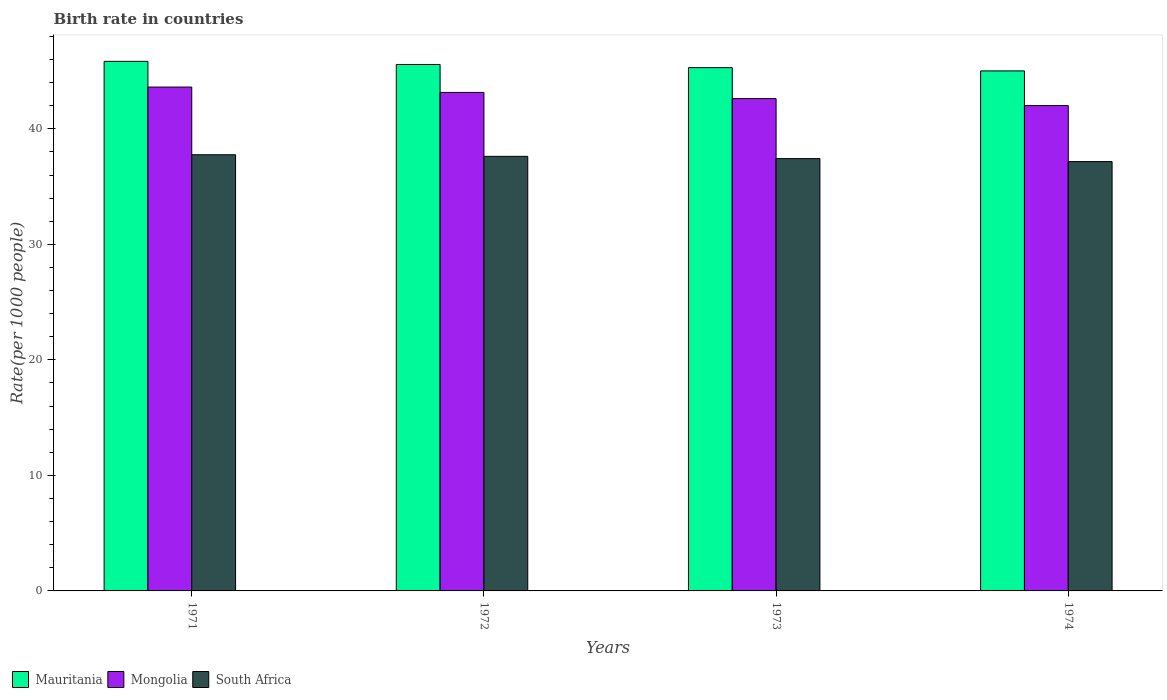How many different coloured bars are there?
Give a very brief answer. 3. Are the number of bars on each tick of the X-axis equal?
Provide a succinct answer. Yes. How many bars are there on the 4th tick from the left?
Your answer should be very brief. 3. What is the birth rate in Mongolia in 1973?
Provide a short and direct response. 42.61. Across all years, what is the maximum birth rate in Mongolia?
Offer a very short reply. 43.61. Across all years, what is the minimum birth rate in South Africa?
Offer a terse response. 37.16. In which year was the birth rate in Mongolia minimum?
Your answer should be very brief. 1974. What is the total birth rate in Mauritania in the graph?
Your response must be concise. 181.71. What is the difference between the birth rate in South Africa in 1972 and that in 1974?
Offer a terse response. 0.45. What is the difference between the birth rate in South Africa in 1972 and the birth rate in Mauritania in 1971?
Keep it short and to the point. -8.22. What is the average birth rate in South Africa per year?
Make the answer very short. 37.49. In the year 1972, what is the difference between the birth rate in Mongolia and birth rate in Mauritania?
Provide a short and direct response. -2.42. What is the ratio of the birth rate in South Africa in 1972 to that in 1973?
Provide a short and direct response. 1.01. Is the birth rate in South Africa in 1973 less than that in 1974?
Keep it short and to the point. No. Is the difference between the birth rate in Mongolia in 1971 and 1973 greater than the difference between the birth rate in Mauritania in 1971 and 1973?
Provide a succinct answer. Yes. What is the difference between the highest and the second highest birth rate in Mauritania?
Your answer should be very brief. 0.27. What is the difference between the highest and the lowest birth rate in Mongolia?
Your answer should be compact. 1.6. In how many years, is the birth rate in South Africa greater than the average birth rate in South Africa taken over all years?
Provide a succinct answer. 2. Is the sum of the birth rate in Mauritania in 1971 and 1972 greater than the maximum birth rate in South Africa across all years?
Your answer should be very brief. Yes. What does the 3rd bar from the left in 1974 represents?
Your response must be concise. South Africa. What does the 2nd bar from the right in 1974 represents?
Your answer should be compact. Mongolia. Is it the case that in every year, the sum of the birth rate in Mongolia and birth rate in South Africa is greater than the birth rate in Mauritania?
Your answer should be very brief. Yes. How many years are there in the graph?
Provide a succinct answer. 4. What is the difference between two consecutive major ticks on the Y-axis?
Offer a terse response. 10. Does the graph contain any zero values?
Your answer should be very brief. No. Does the graph contain grids?
Your response must be concise. No. Where does the legend appear in the graph?
Provide a succinct answer. Bottom left. How many legend labels are there?
Your response must be concise. 3. What is the title of the graph?
Your response must be concise. Birth rate in countries. What is the label or title of the Y-axis?
Your answer should be compact. Rate(per 1000 people). What is the Rate(per 1000 people) of Mauritania in 1971?
Provide a succinct answer. 45.84. What is the Rate(per 1000 people) of Mongolia in 1971?
Offer a very short reply. 43.61. What is the Rate(per 1000 people) in South Africa in 1971?
Your response must be concise. 37.76. What is the Rate(per 1000 people) in Mauritania in 1972?
Ensure brevity in your answer.  45.57. What is the Rate(per 1000 people) of Mongolia in 1972?
Your response must be concise. 43.15. What is the Rate(per 1000 people) in South Africa in 1972?
Keep it short and to the point. 37.62. What is the Rate(per 1000 people) of Mauritania in 1973?
Give a very brief answer. 45.29. What is the Rate(per 1000 people) of Mongolia in 1973?
Offer a very short reply. 42.61. What is the Rate(per 1000 people) in South Africa in 1973?
Keep it short and to the point. 37.42. What is the Rate(per 1000 people) in Mauritania in 1974?
Your answer should be very brief. 45.01. What is the Rate(per 1000 people) of Mongolia in 1974?
Keep it short and to the point. 42.01. What is the Rate(per 1000 people) in South Africa in 1974?
Ensure brevity in your answer.  37.16. Across all years, what is the maximum Rate(per 1000 people) in Mauritania?
Your answer should be compact. 45.84. Across all years, what is the maximum Rate(per 1000 people) in Mongolia?
Your answer should be compact. 43.61. Across all years, what is the maximum Rate(per 1000 people) in South Africa?
Offer a terse response. 37.76. Across all years, what is the minimum Rate(per 1000 people) in Mauritania?
Keep it short and to the point. 45.01. Across all years, what is the minimum Rate(per 1000 people) in Mongolia?
Your answer should be very brief. 42.01. Across all years, what is the minimum Rate(per 1000 people) in South Africa?
Make the answer very short. 37.16. What is the total Rate(per 1000 people) of Mauritania in the graph?
Keep it short and to the point. 181.71. What is the total Rate(per 1000 people) in Mongolia in the graph?
Ensure brevity in your answer.  171.39. What is the total Rate(per 1000 people) in South Africa in the graph?
Give a very brief answer. 149.96. What is the difference between the Rate(per 1000 people) of Mauritania in 1971 and that in 1972?
Give a very brief answer. 0.27. What is the difference between the Rate(per 1000 people) in Mongolia in 1971 and that in 1972?
Provide a short and direct response. 0.46. What is the difference between the Rate(per 1000 people) in South Africa in 1971 and that in 1972?
Your answer should be compact. 0.14. What is the difference between the Rate(per 1000 people) in Mauritania in 1971 and that in 1973?
Your answer should be compact. 0.54. What is the difference between the Rate(per 1000 people) of Mongolia in 1971 and that in 1973?
Keep it short and to the point. 1. What is the difference between the Rate(per 1000 people) in South Africa in 1971 and that in 1973?
Provide a short and direct response. 0.33. What is the difference between the Rate(per 1000 people) of Mauritania in 1971 and that in 1974?
Your answer should be very brief. 0.83. What is the difference between the Rate(per 1000 people) of Mongolia in 1971 and that in 1974?
Offer a terse response. 1.6. What is the difference between the Rate(per 1000 people) of South Africa in 1971 and that in 1974?
Provide a succinct answer. 0.59. What is the difference between the Rate(per 1000 people) in Mauritania in 1972 and that in 1973?
Provide a succinct answer. 0.27. What is the difference between the Rate(per 1000 people) of Mongolia in 1972 and that in 1973?
Provide a succinct answer. 0.54. What is the difference between the Rate(per 1000 people) of South Africa in 1972 and that in 1973?
Your answer should be very brief. 0.19. What is the difference between the Rate(per 1000 people) of Mauritania in 1972 and that in 1974?
Your response must be concise. 0.56. What is the difference between the Rate(per 1000 people) of Mongolia in 1972 and that in 1974?
Offer a terse response. 1.14. What is the difference between the Rate(per 1000 people) of South Africa in 1972 and that in 1974?
Give a very brief answer. 0.45. What is the difference between the Rate(per 1000 people) in Mauritania in 1973 and that in 1974?
Your response must be concise. 0.28. What is the difference between the Rate(per 1000 people) in Mongolia in 1973 and that in 1974?
Your response must be concise. 0.6. What is the difference between the Rate(per 1000 people) in South Africa in 1973 and that in 1974?
Your response must be concise. 0.26. What is the difference between the Rate(per 1000 people) in Mauritania in 1971 and the Rate(per 1000 people) in Mongolia in 1972?
Ensure brevity in your answer.  2.69. What is the difference between the Rate(per 1000 people) in Mauritania in 1971 and the Rate(per 1000 people) in South Africa in 1972?
Your answer should be compact. 8.22. What is the difference between the Rate(per 1000 people) of Mongolia in 1971 and the Rate(per 1000 people) of South Africa in 1972?
Offer a very short reply. 6. What is the difference between the Rate(per 1000 people) in Mauritania in 1971 and the Rate(per 1000 people) in Mongolia in 1973?
Provide a short and direct response. 3.22. What is the difference between the Rate(per 1000 people) of Mauritania in 1971 and the Rate(per 1000 people) of South Africa in 1973?
Your answer should be very brief. 8.42. What is the difference between the Rate(per 1000 people) of Mongolia in 1971 and the Rate(per 1000 people) of South Africa in 1973?
Ensure brevity in your answer.  6.19. What is the difference between the Rate(per 1000 people) in Mauritania in 1971 and the Rate(per 1000 people) in Mongolia in 1974?
Offer a very short reply. 3.83. What is the difference between the Rate(per 1000 people) in Mauritania in 1971 and the Rate(per 1000 people) in South Africa in 1974?
Give a very brief answer. 8.67. What is the difference between the Rate(per 1000 people) in Mongolia in 1971 and the Rate(per 1000 people) in South Africa in 1974?
Keep it short and to the point. 6.45. What is the difference between the Rate(per 1000 people) of Mauritania in 1972 and the Rate(per 1000 people) of Mongolia in 1973?
Ensure brevity in your answer.  2.95. What is the difference between the Rate(per 1000 people) in Mauritania in 1972 and the Rate(per 1000 people) in South Africa in 1973?
Offer a terse response. 8.15. What is the difference between the Rate(per 1000 people) of Mongolia in 1972 and the Rate(per 1000 people) of South Africa in 1973?
Your answer should be compact. 5.73. What is the difference between the Rate(per 1000 people) of Mauritania in 1972 and the Rate(per 1000 people) of Mongolia in 1974?
Provide a succinct answer. 3.56. What is the difference between the Rate(per 1000 people) of Mauritania in 1972 and the Rate(per 1000 people) of South Africa in 1974?
Provide a succinct answer. 8.4. What is the difference between the Rate(per 1000 people) in Mongolia in 1972 and the Rate(per 1000 people) in South Africa in 1974?
Give a very brief answer. 5.99. What is the difference between the Rate(per 1000 people) of Mauritania in 1973 and the Rate(per 1000 people) of Mongolia in 1974?
Provide a short and direct response. 3.29. What is the difference between the Rate(per 1000 people) in Mauritania in 1973 and the Rate(per 1000 people) in South Africa in 1974?
Provide a short and direct response. 8.13. What is the difference between the Rate(per 1000 people) in Mongolia in 1973 and the Rate(per 1000 people) in South Africa in 1974?
Your answer should be compact. 5.45. What is the average Rate(per 1000 people) of Mauritania per year?
Make the answer very short. 45.43. What is the average Rate(per 1000 people) in Mongolia per year?
Offer a very short reply. 42.85. What is the average Rate(per 1000 people) in South Africa per year?
Your answer should be very brief. 37.49. In the year 1971, what is the difference between the Rate(per 1000 people) in Mauritania and Rate(per 1000 people) in Mongolia?
Offer a terse response. 2.23. In the year 1971, what is the difference between the Rate(per 1000 people) of Mauritania and Rate(per 1000 people) of South Africa?
Your answer should be very brief. 8.08. In the year 1971, what is the difference between the Rate(per 1000 people) of Mongolia and Rate(per 1000 people) of South Africa?
Offer a very short reply. 5.86. In the year 1972, what is the difference between the Rate(per 1000 people) in Mauritania and Rate(per 1000 people) in Mongolia?
Your answer should be very brief. 2.42. In the year 1972, what is the difference between the Rate(per 1000 people) in Mauritania and Rate(per 1000 people) in South Africa?
Offer a very short reply. 7.95. In the year 1972, what is the difference between the Rate(per 1000 people) in Mongolia and Rate(per 1000 people) in South Africa?
Make the answer very short. 5.54. In the year 1973, what is the difference between the Rate(per 1000 people) in Mauritania and Rate(per 1000 people) in Mongolia?
Offer a very short reply. 2.68. In the year 1973, what is the difference between the Rate(per 1000 people) of Mauritania and Rate(per 1000 people) of South Africa?
Your response must be concise. 7.87. In the year 1973, what is the difference between the Rate(per 1000 people) in Mongolia and Rate(per 1000 people) in South Africa?
Offer a terse response. 5.19. In the year 1974, what is the difference between the Rate(per 1000 people) in Mauritania and Rate(per 1000 people) in Mongolia?
Your answer should be very brief. 3. In the year 1974, what is the difference between the Rate(per 1000 people) in Mauritania and Rate(per 1000 people) in South Africa?
Your answer should be compact. 7.85. In the year 1974, what is the difference between the Rate(per 1000 people) of Mongolia and Rate(per 1000 people) of South Africa?
Give a very brief answer. 4.84. What is the ratio of the Rate(per 1000 people) of Mauritania in 1971 to that in 1972?
Your answer should be very brief. 1.01. What is the ratio of the Rate(per 1000 people) in Mongolia in 1971 to that in 1972?
Your answer should be very brief. 1.01. What is the ratio of the Rate(per 1000 people) in Mauritania in 1971 to that in 1973?
Ensure brevity in your answer.  1.01. What is the ratio of the Rate(per 1000 people) in Mongolia in 1971 to that in 1973?
Your answer should be very brief. 1.02. What is the ratio of the Rate(per 1000 people) in South Africa in 1971 to that in 1973?
Keep it short and to the point. 1.01. What is the ratio of the Rate(per 1000 people) of Mauritania in 1971 to that in 1974?
Your answer should be compact. 1.02. What is the ratio of the Rate(per 1000 people) in Mongolia in 1971 to that in 1974?
Provide a short and direct response. 1.04. What is the ratio of the Rate(per 1000 people) in South Africa in 1971 to that in 1974?
Ensure brevity in your answer.  1.02. What is the ratio of the Rate(per 1000 people) in Mauritania in 1972 to that in 1973?
Your answer should be very brief. 1.01. What is the ratio of the Rate(per 1000 people) of Mongolia in 1972 to that in 1973?
Make the answer very short. 1.01. What is the ratio of the Rate(per 1000 people) of South Africa in 1972 to that in 1973?
Give a very brief answer. 1.01. What is the ratio of the Rate(per 1000 people) of Mauritania in 1972 to that in 1974?
Ensure brevity in your answer.  1.01. What is the ratio of the Rate(per 1000 people) in Mongolia in 1972 to that in 1974?
Your answer should be compact. 1.03. What is the ratio of the Rate(per 1000 people) of South Africa in 1972 to that in 1974?
Offer a terse response. 1.01. What is the ratio of the Rate(per 1000 people) of Mauritania in 1973 to that in 1974?
Offer a terse response. 1.01. What is the ratio of the Rate(per 1000 people) in Mongolia in 1973 to that in 1974?
Provide a short and direct response. 1.01. What is the ratio of the Rate(per 1000 people) in South Africa in 1973 to that in 1974?
Offer a terse response. 1.01. What is the difference between the highest and the second highest Rate(per 1000 people) in Mauritania?
Offer a very short reply. 0.27. What is the difference between the highest and the second highest Rate(per 1000 people) in Mongolia?
Your answer should be compact. 0.46. What is the difference between the highest and the second highest Rate(per 1000 people) of South Africa?
Ensure brevity in your answer.  0.14. What is the difference between the highest and the lowest Rate(per 1000 people) in Mauritania?
Your answer should be very brief. 0.83. What is the difference between the highest and the lowest Rate(per 1000 people) in Mongolia?
Your answer should be very brief. 1.6. What is the difference between the highest and the lowest Rate(per 1000 people) of South Africa?
Keep it short and to the point. 0.59. 